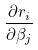Convert formula to latex. <formula><loc_0><loc_0><loc_500><loc_500>\frac { \partial r _ { i } } { \partial \beta _ { j } }</formula> 